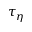Convert formula to latex. <formula><loc_0><loc_0><loc_500><loc_500>\tau _ { \eta }</formula> 